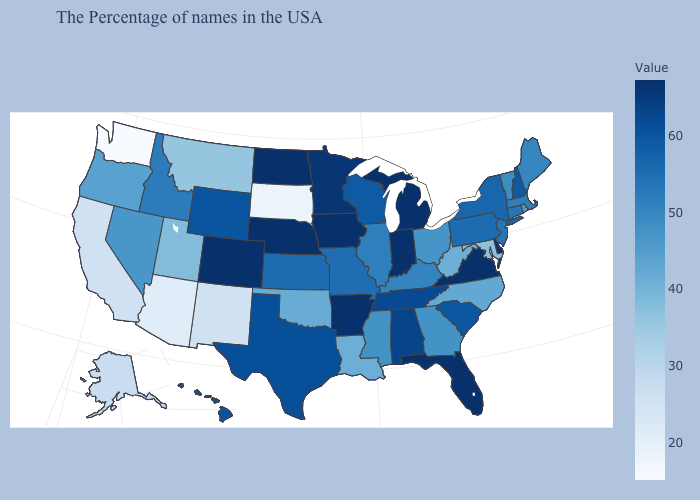Does Wyoming have a higher value than Louisiana?
Quick response, please. Yes. Does Texas have a lower value than Delaware?
Short answer required. Yes. Does the map have missing data?
Keep it brief. No. Does South Dakota have the lowest value in the USA?
Be succinct. No. Among the states that border New Jersey , which have the highest value?
Write a very short answer. Delaware. Which states have the lowest value in the South?
Answer briefly. Maryland. Does Washington have the lowest value in the USA?
Short answer required. Yes. Does Michigan have the highest value in the USA?
Answer briefly. Yes. 